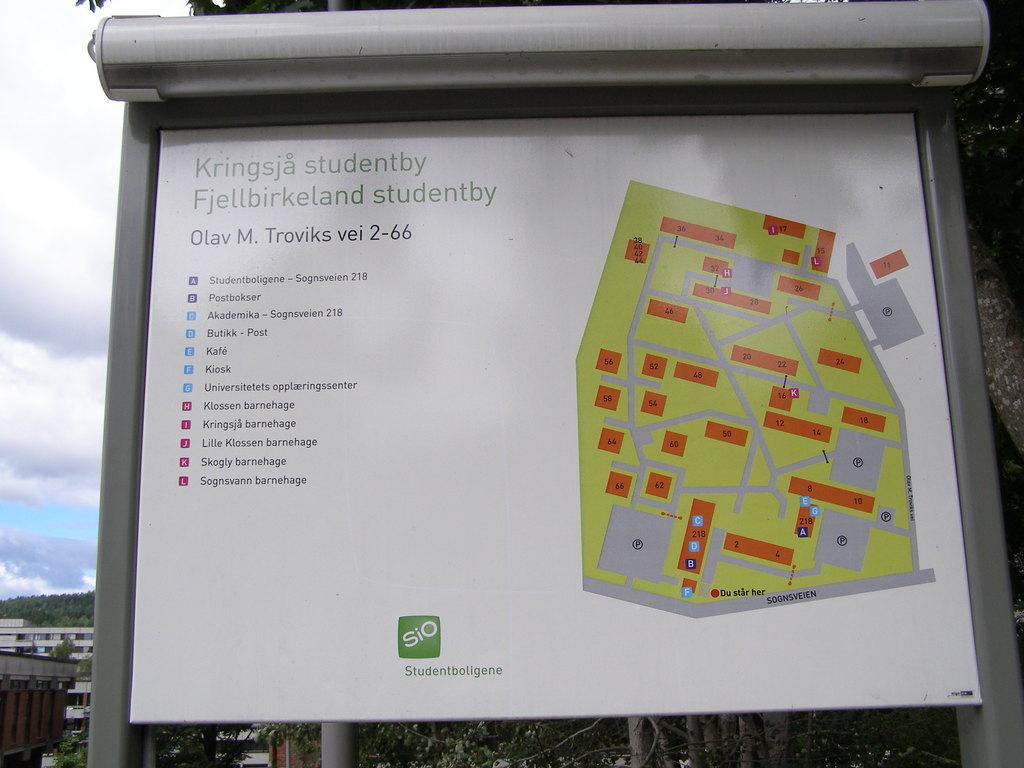What company is on the map?
Provide a short and direct response. Sio. 